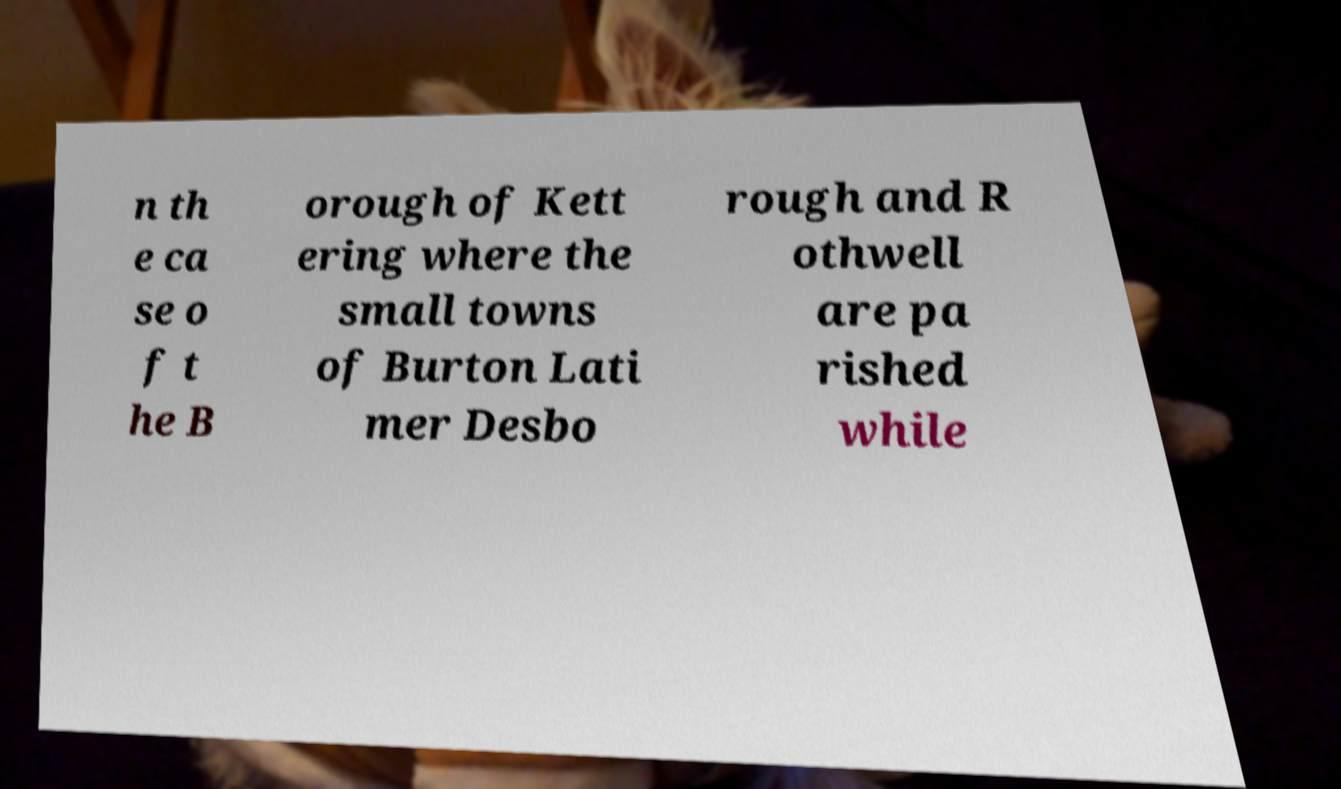For documentation purposes, I need the text within this image transcribed. Could you provide that? n th e ca se o f t he B orough of Kett ering where the small towns of Burton Lati mer Desbo rough and R othwell are pa rished while 